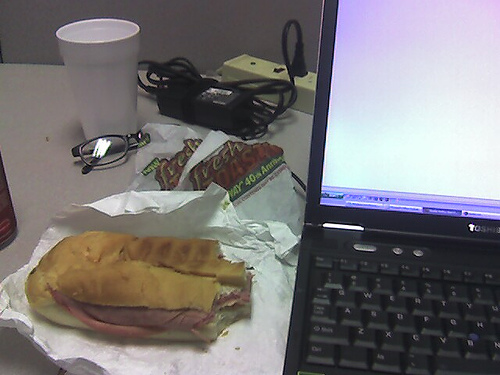How many laptops can be seen? 1 